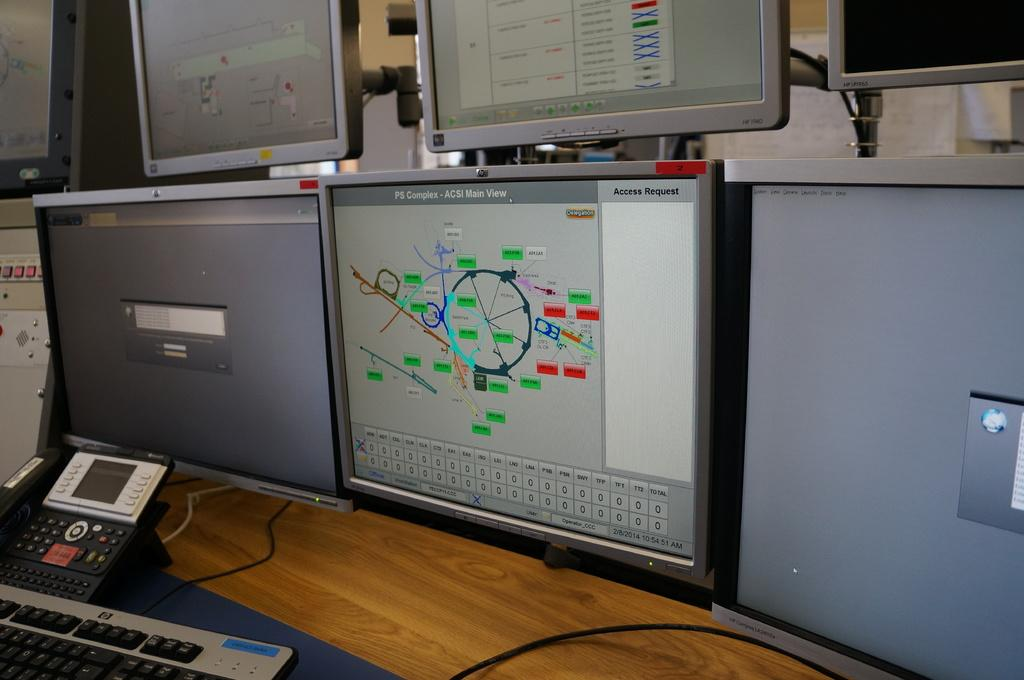<image>
Share a concise interpretation of the image provided. A computer monitor says "PS Complex" at the top of it. 